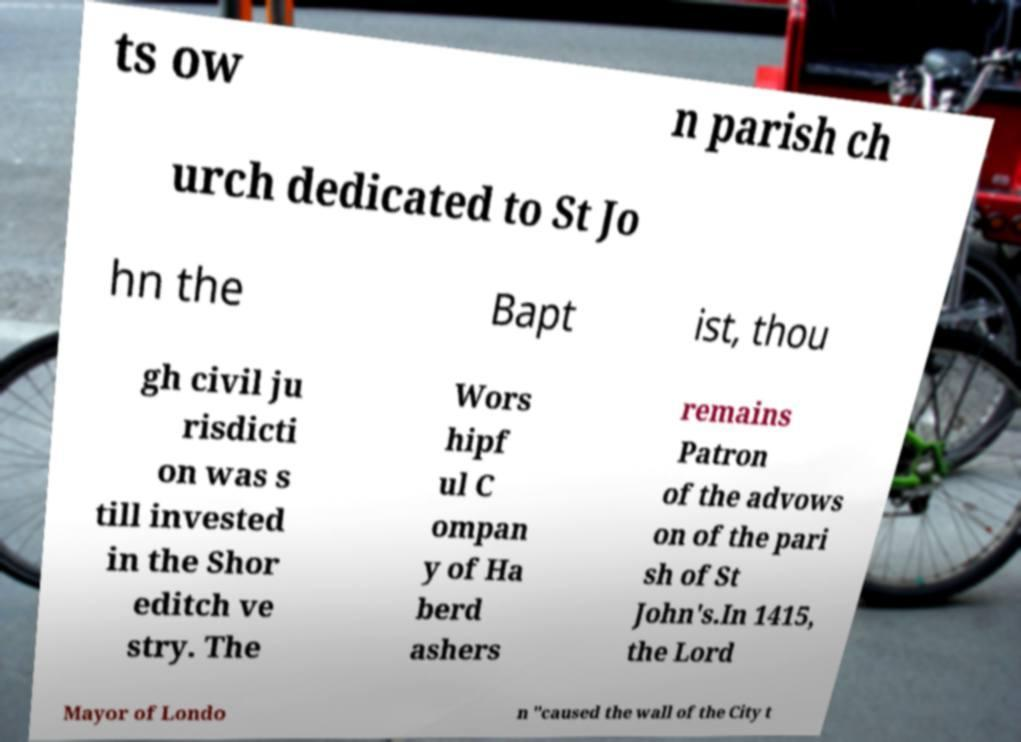For documentation purposes, I need the text within this image transcribed. Could you provide that? ts ow n parish ch urch dedicated to St Jo hn the Bapt ist, thou gh civil ju risdicti on was s till invested in the Shor editch ve stry. The Wors hipf ul C ompan y of Ha berd ashers remains Patron of the advows on of the pari sh of St John's.In 1415, the Lord Mayor of Londo n "caused the wall of the City t 